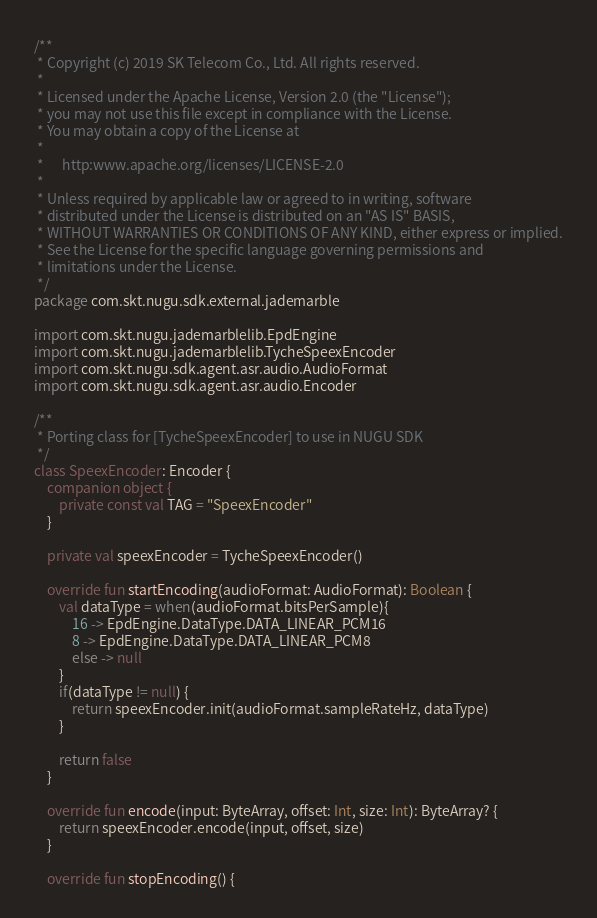Convert code to text. <code><loc_0><loc_0><loc_500><loc_500><_Kotlin_>/**
 * Copyright (c) 2019 SK Telecom Co., Ltd. All rights reserved.
 *
 * Licensed under the Apache License, Version 2.0 (the "License");
 * you may not use this file except in compliance with the License.
 * You may obtain a copy of the License at
 *
 *      http:www.apache.org/licenses/LICENSE-2.0
 *
 * Unless required by applicable law or agreed to in writing, software
 * distributed under the License is distributed on an "AS IS" BASIS,
 * WITHOUT WARRANTIES OR CONDITIONS OF ANY KIND, either express or implied.
 * See the License for the specific language governing permissions and
 * limitations under the License.
 */
package com.skt.nugu.sdk.external.jademarble

import com.skt.nugu.jademarblelib.EpdEngine
import com.skt.nugu.jademarblelib.TycheSpeexEncoder
import com.skt.nugu.sdk.agent.asr.audio.AudioFormat
import com.skt.nugu.sdk.agent.asr.audio.Encoder

/**
 * Porting class for [TycheSpeexEncoder] to use in NUGU SDK
 */
class SpeexEncoder: Encoder {
    companion object {
        private const val TAG = "SpeexEncoder"
    }

    private val speexEncoder = TycheSpeexEncoder()

    override fun startEncoding(audioFormat: AudioFormat): Boolean {
        val dataType = when(audioFormat.bitsPerSample){
            16 -> EpdEngine.DataType.DATA_LINEAR_PCM16
            8 -> EpdEngine.DataType.DATA_LINEAR_PCM8
            else -> null
        }
        if(dataType != null) {
            return speexEncoder.init(audioFormat.sampleRateHz, dataType)
        }

        return false
    }

    override fun encode(input: ByteArray, offset: Int, size: Int): ByteArray? {
        return speexEncoder.encode(input, offset, size)
    }

    override fun stopEncoding() {</code> 